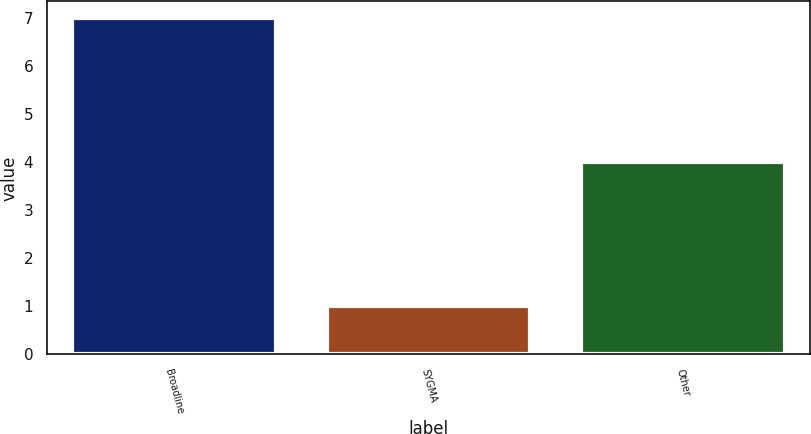<chart> <loc_0><loc_0><loc_500><loc_500><bar_chart><fcel>Broadline<fcel>SYGMA<fcel>Other<nl><fcel>7<fcel>1<fcel>4<nl></chart> 